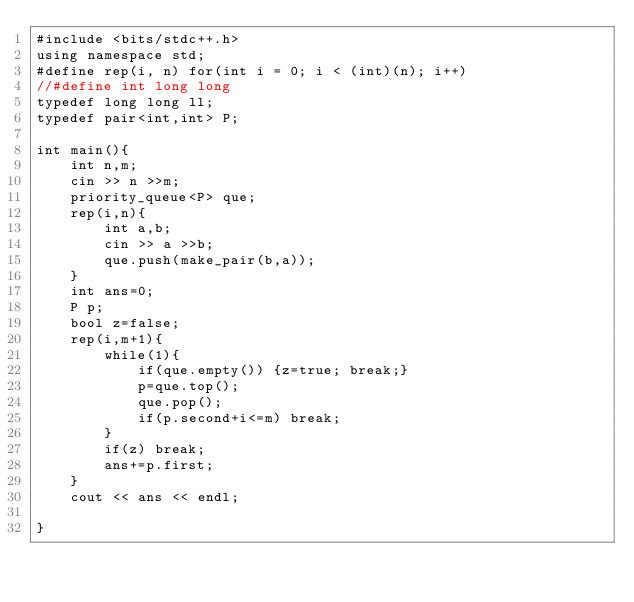Convert code to text. <code><loc_0><loc_0><loc_500><loc_500><_C++_>#include <bits/stdc++.h>
using namespace std;
#define rep(i, n) for(int i = 0; i < (int)(n); i++)
//#define int long long
typedef long long ll;
typedef pair<int,int> P;

int main(){
    int n,m;
    cin >> n >>m;
    priority_queue<P> que;
    rep(i,n){
        int a,b;
        cin >> a >>b;
        que.push(make_pair(b,a));
    }
    int ans=0;
    P p;
    bool z=false;
    rep(i,m+1){
        while(1){
            if(que.empty()) {z=true; break;}
            p=que.top();
            que.pop();
            if(p.second+i<=m) break;
        }
        if(z) break;
        ans+=p.first;
    }
    cout << ans << endl;

}</code> 